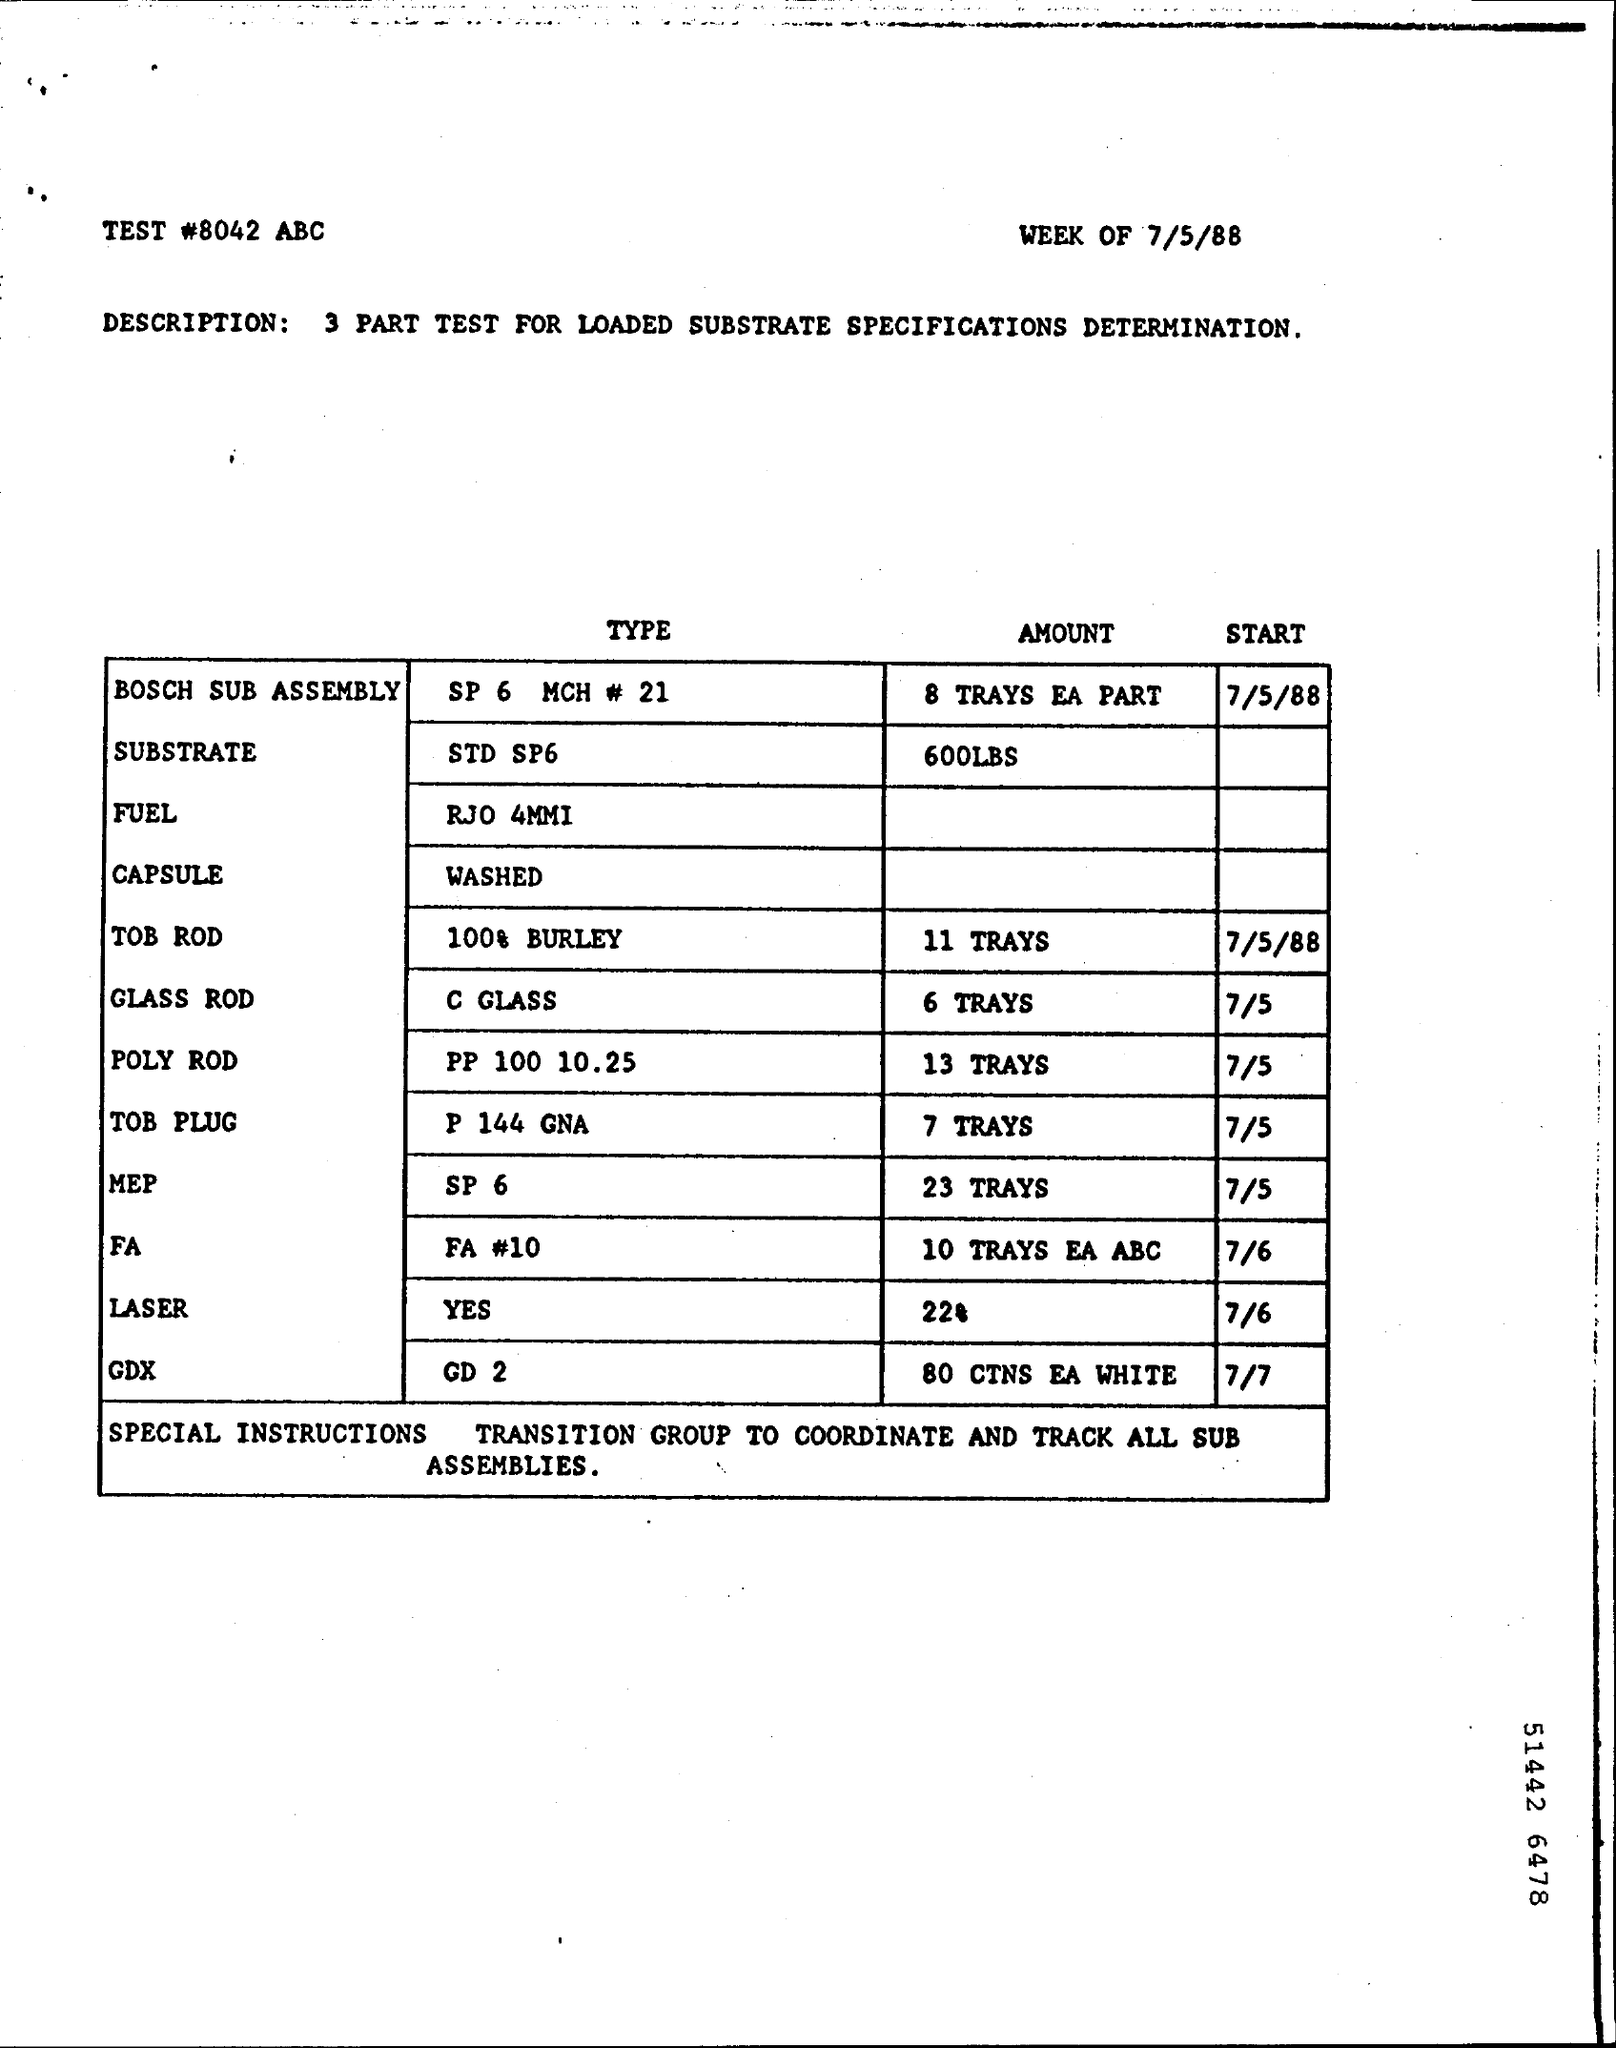What is the Test#?
Your answer should be compact. 8042. What is the Amount of TOB ROD?
Offer a terse response. 11 Trays. What is the Amount of Glass Rod?
Offer a terse response. 6 Trays. What is the Amount of Poly Rod?
Offer a terse response. 13 Trays. What is the Amount of Tob Plug?
Provide a short and direct response. 7 TRAYS. What is the Amount of MEP?
Your answer should be compact. 23 TRAYS. What is the Amount of FA?
Offer a very short reply. 10 TRAYS EA ABC. What is the Amount of Laser?
Your answer should be compact. 22. What is the Amount of GDX?
Give a very brief answer. 80 CTNS EA WHITE. What is the Start of GDX?
Offer a terse response. 7/7. 